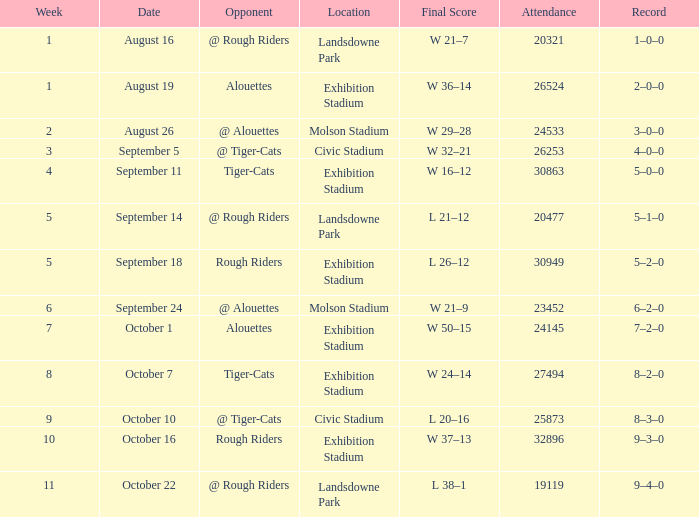For the date of september 5, what is the count of attendance values? 1.0. 